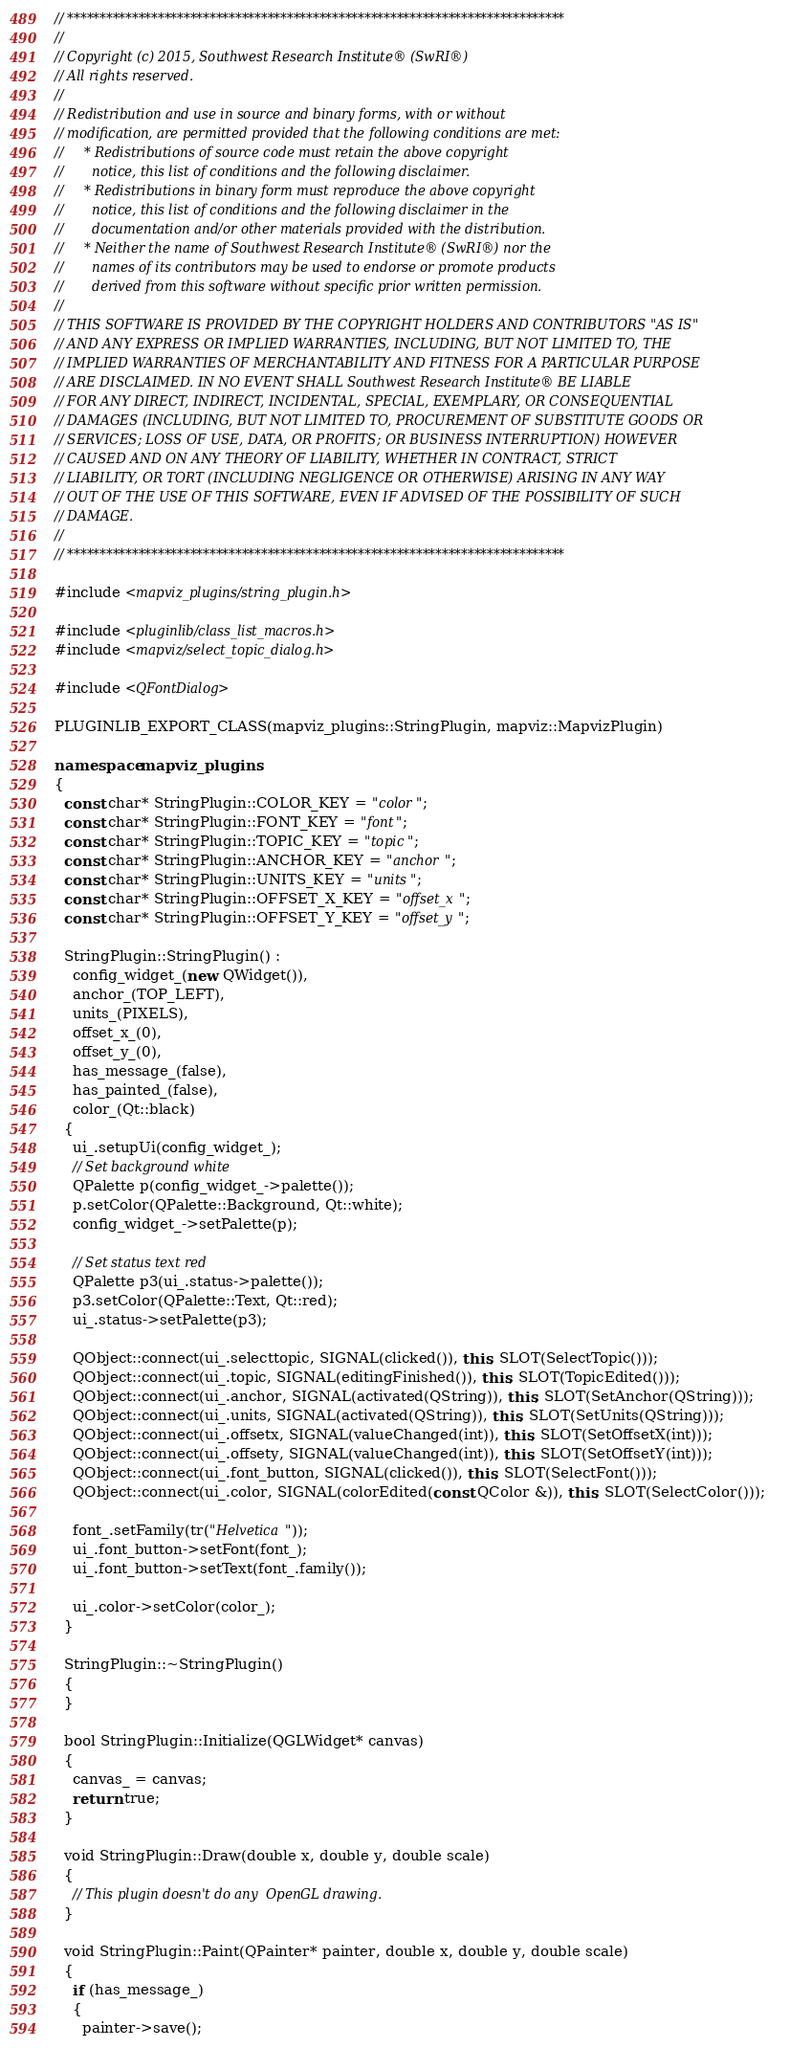<code> <loc_0><loc_0><loc_500><loc_500><_C++_>// *****************************************************************************
//
// Copyright (c) 2015, Southwest Research Institute® (SwRI®)
// All rights reserved.
//
// Redistribution and use in source and binary forms, with or without
// modification, are permitted provided that the following conditions are met:
//     * Redistributions of source code must retain the above copyright
//       notice, this list of conditions and the following disclaimer.
//     * Redistributions in binary form must reproduce the above copyright
//       notice, this list of conditions and the following disclaimer in the
//       documentation and/or other materials provided with the distribution.
//     * Neither the name of Southwest Research Institute® (SwRI®) nor the
//       names of its contributors may be used to endorse or promote products
//       derived from this software without specific prior written permission.
//
// THIS SOFTWARE IS PROVIDED BY THE COPYRIGHT HOLDERS AND CONTRIBUTORS "AS IS"
// AND ANY EXPRESS OR IMPLIED WARRANTIES, INCLUDING, BUT NOT LIMITED TO, THE
// IMPLIED WARRANTIES OF MERCHANTABILITY AND FITNESS FOR A PARTICULAR PURPOSE
// ARE DISCLAIMED. IN NO EVENT SHALL Southwest Research Institute® BE LIABLE 
// FOR ANY DIRECT, INDIRECT, INCIDENTAL, SPECIAL, EXEMPLARY, OR CONSEQUENTIAL 
// DAMAGES (INCLUDING, BUT NOT LIMITED TO, PROCUREMENT OF SUBSTITUTE GOODS OR 
// SERVICES; LOSS OF USE, DATA, OR PROFITS; OR BUSINESS INTERRUPTION) HOWEVER 
// CAUSED AND ON ANY THEORY OF LIABILITY, WHETHER IN CONTRACT, STRICT 
// LIABILITY, OR TORT (INCLUDING NEGLIGENCE OR OTHERWISE) ARISING IN ANY WAY 
// OUT OF THE USE OF THIS SOFTWARE, EVEN IF ADVISED OF THE POSSIBILITY OF SUCH
// DAMAGE.
//
// *****************************************************************************

#include <mapviz_plugins/string_plugin.h>

#include <pluginlib/class_list_macros.h>
#include <mapviz/select_topic_dialog.h>

#include <QFontDialog>

PLUGINLIB_EXPORT_CLASS(mapviz_plugins::StringPlugin, mapviz::MapvizPlugin)

namespace mapviz_plugins
{
  const char* StringPlugin::COLOR_KEY = "color";
  const char* StringPlugin::FONT_KEY = "font";
  const char* StringPlugin::TOPIC_KEY = "topic";
  const char* StringPlugin::ANCHOR_KEY = "anchor";
  const char* StringPlugin::UNITS_KEY = "units";
  const char* StringPlugin::OFFSET_X_KEY = "offset_x";
  const char* StringPlugin::OFFSET_Y_KEY = "offset_y";

  StringPlugin::StringPlugin() :
    config_widget_(new QWidget()),
    anchor_(TOP_LEFT),
    units_(PIXELS),
    offset_x_(0),
    offset_y_(0),
    has_message_(false),
    has_painted_(false),
    color_(Qt::black)
  {
    ui_.setupUi(config_widget_);
    // Set background white
    QPalette p(config_widget_->palette());
    p.setColor(QPalette::Background, Qt::white);
    config_widget_->setPalette(p);

    // Set status text red
    QPalette p3(ui_.status->palette());
    p3.setColor(QPalette::Text, Qt::red);
    ui_.status->setPalette(p3);

    QObject::connect(ui_.selecttopic, SIGNAL(clicked()), this, SLOT(SelectTopic()));
    QObject::connect(ui_.topic, SIGNAL(editingFinished()), this, SLOT(TopicEdited()));
    QObject::connect(ui_.anchor, SIGNAL(activated(QString)), this, SLOT(SetAnchor(QString)));
    QObject::connect(ui_.units, SIGNAL(activated(QString)), this, SLOT(SetUnits(QString)));
    QObject::connect(ui_.offsetx, SIGNAL(valueChanged(int)), this, SLOT(SetOffsetX(int)));
    QObject::connect(ui_.offsety, SIGNAL(valueChanged(int)), this, SLOT(SetOffsetY(int)));
    QObject::connect(ui_.font_button, SIGNAL(clicked()), this, SLOT(SelectFont()));
    QObject::connect(ui_.color, SIGNAL(colorEdited(const QColor &)), this, SLOT(SelectColor()));

    font_.setFamily(tr("Helvetica"));
    ui_.font_button->setFont(font_);
    ui_.font_button->setText(font_.family());

    ui_.color->setColor(color_);
  }

  StringPlugin::~StringPlugin()
  {
  }

  bool StringPlugin::Initialize(QGLWidget* canvas)
  {
    canvas_ = canvas;
    return true;
  }

  void StringPlugin::Draw(double x, double y, double scale)
  {
    // This plugin doesn't do any  OpenGL drawing.
  }

  void StringPlugin::Paint(QPainter* painter, double x, double y, double scale)
  {
    if (has_message_)
    {
      painter->save();</code> 